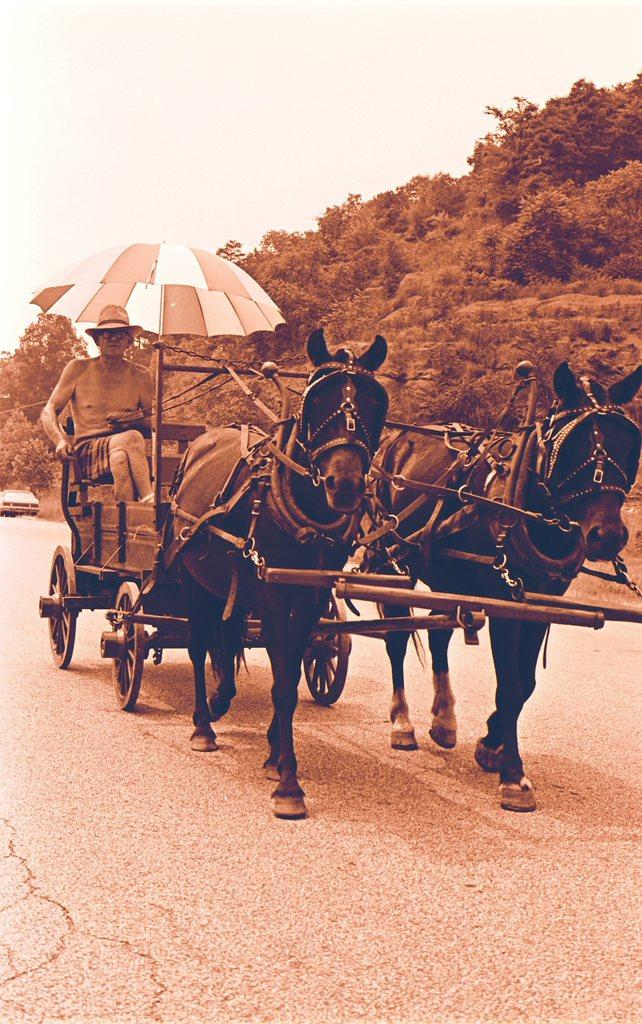What is the main subject of the image? There is a man in the image. What is the man wearing? The man is wearing spectacles. What is the man doing in the image? The man is sitting and driving a horse cart. Where is the horse cart located? The horse cart is on the road. What can be seen in the background of the image? There is a hill, a car, and grass in the background of the image. What type of whip is the man using to control the horse in the image? There is no whip visible in the image; the man is driving the horse cart without a whip. What type of collar is the horse wearing in the image? There is no collar visible on the horse in the image. 